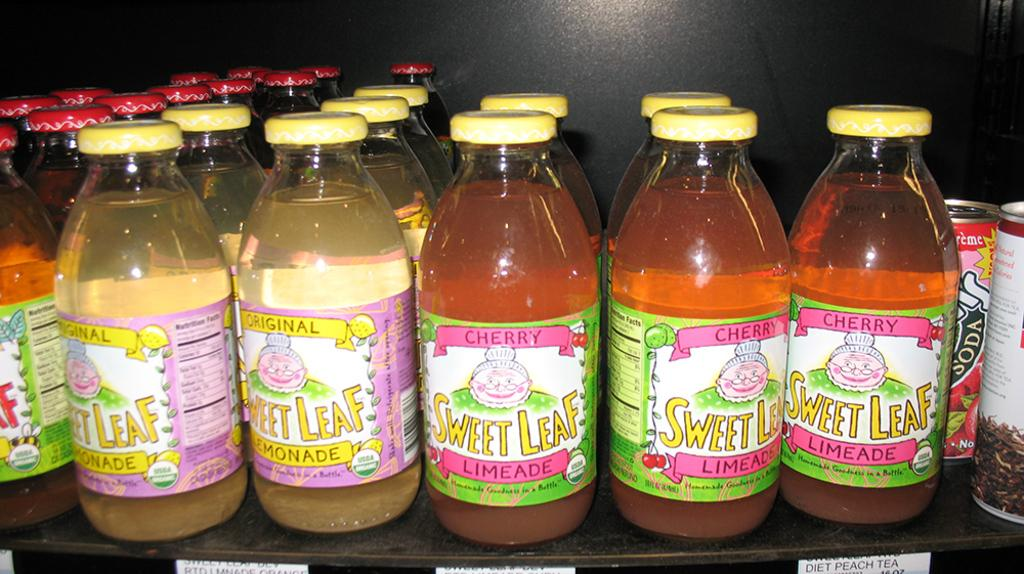<image>
Give a short and clear explanation of the subsequent image. Bottles with Sweet Leaf Leaf Lemonade and Limeade with a round label that has USDA printed on it. 